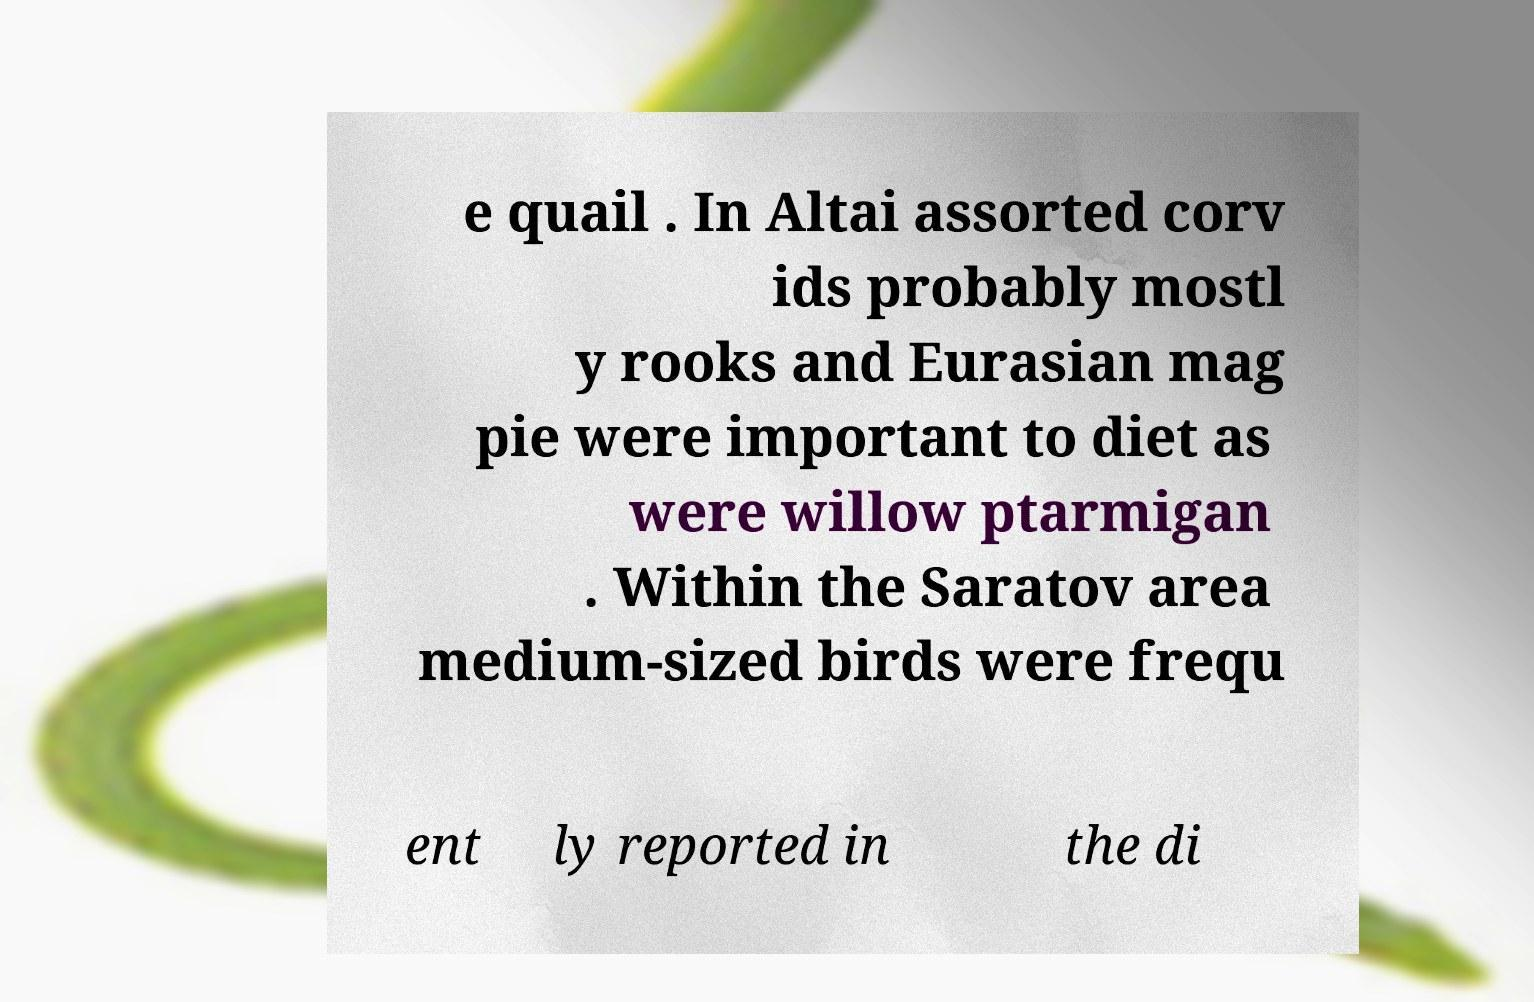Could you assist in decoding the text presented in this image and type it out clearly? e quail . In Altai assorted corv ids probably mostl y rooks and Eurasian mag pie were important to diet as were willow ptarmigan . Within the Saratov area medium-sized birds were frequ ent ly reported in the di 